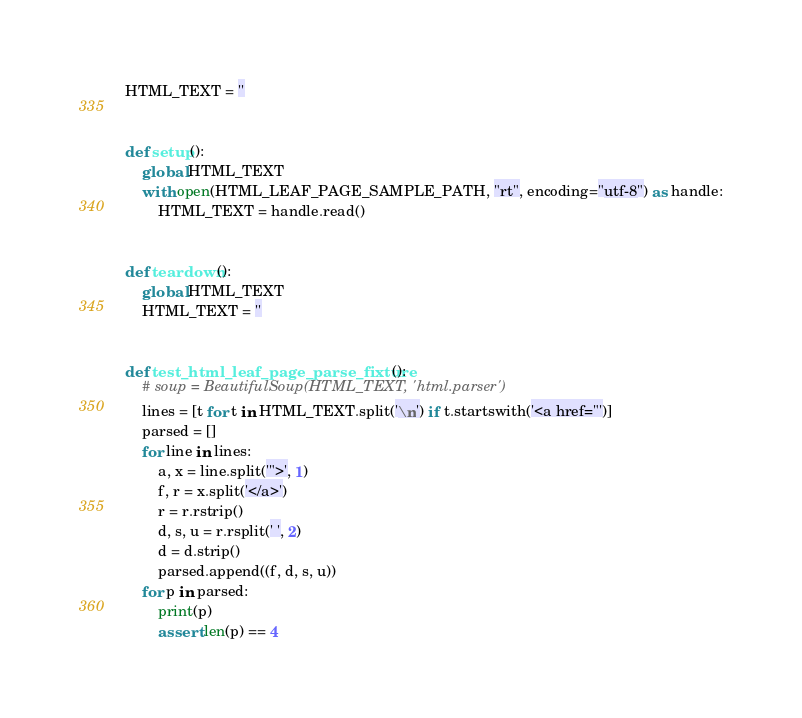<code> <loc_0><loc_0><loc_500><loc_500><_Python_>HTML_TEXT = ''


def setup():
    global HTML_TEXT
    with open(HTML_LEAF_PAGE_SAMPLE_PATH, "rt", encoding="utf-8") as handle:
        HTML_TEXT = handle.read()


def teardown():
    global HTML_TEXT
    HTML_TEXT = ''


def test_html_leaf_page_parse_fixture():
    # soup = BeautifulSoup(HTML_TEXT, 'html.parser')
    lines = [t for t in HTML_TEXT.split('\n') if t.startswith('<a href="')]
    parsed = []
    for line in lines:
        a, x = line.split('">', 1)
        f, r = x.split('</a>')
        r = r.rstrip()
        d, s, u = r.rsplit(' ', 2)
        d = d.strip()
        parsed.append((f, d, s, u))
    for p in parsed:
        print(p)
        assert len(p) == 4
</code> 